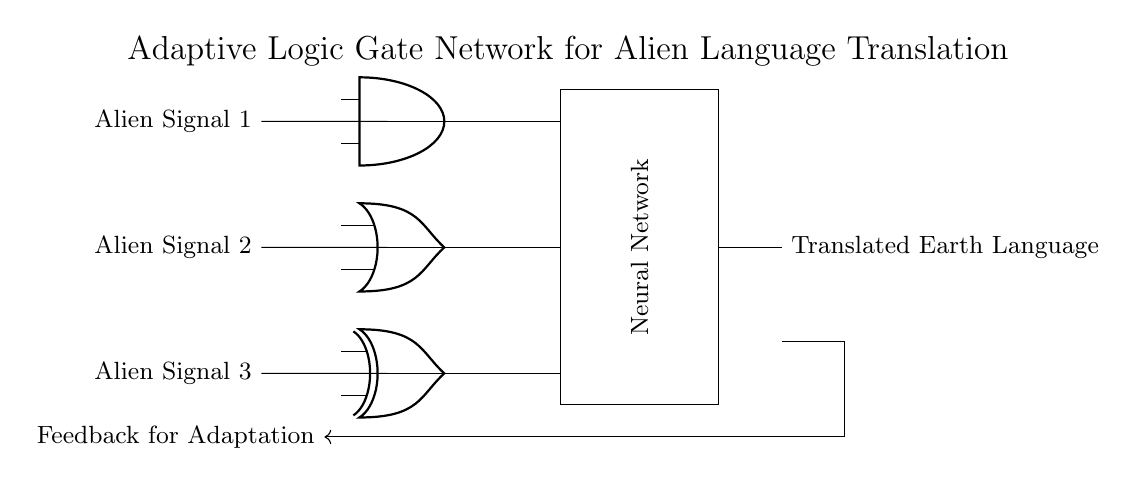What are the input signals of the circuit? The input signals are Alien Signal 1, Alien Signal 2, and Alien Signal 3, as labeled on the left side of the circuit.
Answer: Alien Signal 1, Alien Signal 2, Alien Signal 3 What type of logic gate is connected to Alien Signal 2? The logic gate connected to Alien Signal 2 is an OR gate, as indicated in the circuit where the second input line feeds into the OR port.
Answer: OR What is the output of the AND gate when all inputs are high? The AND gate outputs a high signal only when all inputs are high, meaning the output will be high if Alien Signal 1 is high.
Answer: High Which component processes the outputs from the logic gates? The outputs from the logic gates (AND, OR, XOR) are processed by a Neural Network, which is shown as a rectangular box in the diagram.
Answer: Neural Network How does the circuit adapt to new input signals? The circuit adapts through a feedback loop connected to the Neural Network, allowing it to modify its processing based on the translated Earth language output.
Answer: Feedback loop What are the outputs of the logic gates before they reach the Neural Network? The outputs before reaching the Neural Network are generated by the AND, OR, and XOR gates, feeding into the Neural Network concurrently.
Answer: AND, OR, XOR outputs Which gate would produce different outputs for the same inputs? The XOR gate will produce different outputs for the same inputs, specifically it outputs high only for non-matching input combinations.
Answer: XOR 